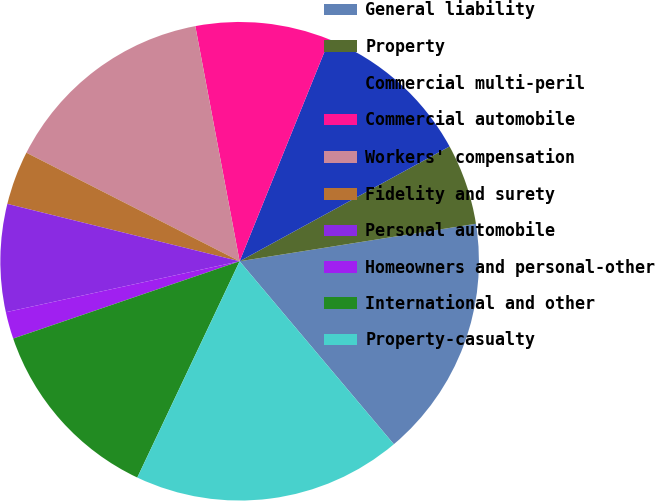Convert chart to OTSL. <chart><loc_0><loc_0><loc_500><loc_500><pie_chart><fcel>General liability<fcel>Property<fcel>Commercial multi-peril<fcel>Commercial automobile<fcel>Workers' compensation<fcel>Fidelity and surety<fcel>Personal automobile<fcel>Homeowners and personal-other<fcel>International and other<fcel>Property-casualty<nl><fcel>16.36%<fcel>5.46%<fcel>10.91%<fcel>9.09%<fcel>14.54%<fcel>3.64%<fcel>7.27%<fcel>1.82%<fcel>12.73%<fcel>18.18%<nl></chart> 